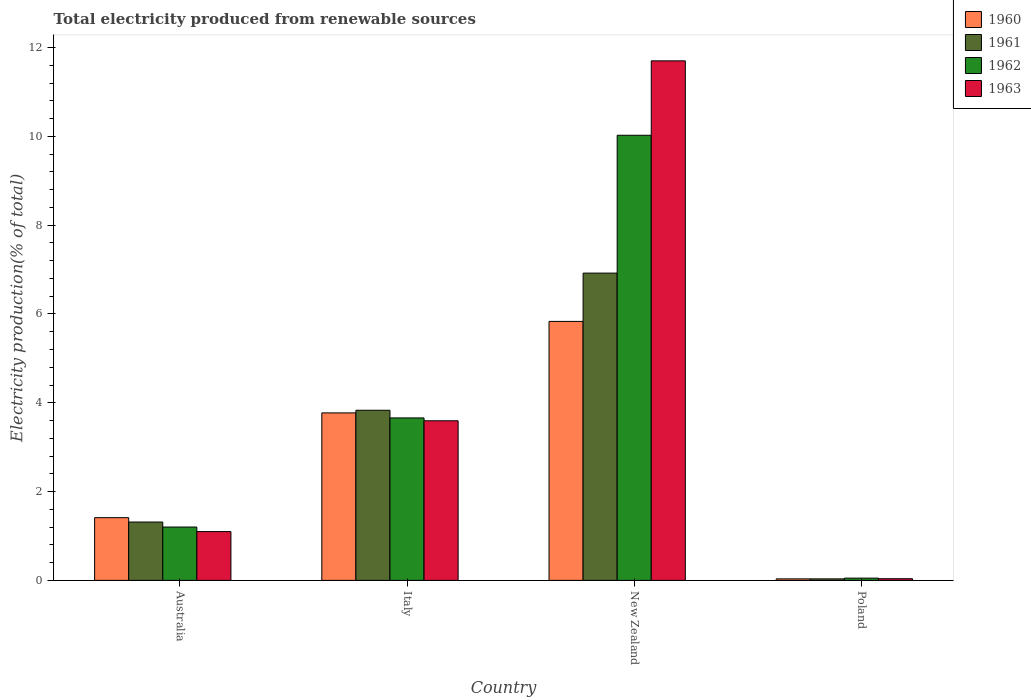How many different coloured bars are there?
Give a very brief answer. 4. How many groups of bars are there?
Your answer should be compact. 4. Are the number of bars per tick equal to the number of legend labels?
Provide a short and direct response. Yes. Are the number of bars on each tick of the X-axis equal?
Provide a succinct answer. Yes. How many bars are there on the 4th tick from the left?
Provide a succinct answer. 4. How many bars are there on the 3rd tick from the right?
Provide a short and direct response. 4. What is the label of the 3rd group of bars from the left?
Offer a very short reply. New Zealand. What is the total electricity produced in 1963 in New Zealand?
Give a very brief answer. 11.7. Across all countries, what is the maximum total electricity produced in 1962?
Your response must be concise. 10.02. Across all countries, what is the minimum total electricity produced in 1960?
Your answer should be very brief. 0.03. In which country was the total electricity produced in 1963 maximum?
Ensure brevity in your answer.  New Zealand. What is the total total electricity produced in 1961 in the graph?
Make the answer very short. 12.1. What is the difference between the total electricity produced in 1962 in New Zealand and that in Poland?
Keep it short and to the point. 9.97. What is the difference between the total electricity produced in 1962 in Australia and the total electricity produced in 1961 in Italy?
Your answer should be very brief. -2.63. What is the average total electricity produced in 1962 per country?
Your answer should be compact. 3.73. What is the difference between the total electricity produced of/in 1962 and total electricity produced of/in 1963 in Poland?
Your answer should be compact. 0.01. What is the ratio of the total electricity produced in 1961 in Australia to that in New Zealand?
Provide a short and direct response. 0.19. Is the difference between the total electricity produced in 1962 in Italy and New Zealand greater than the difference between the total electricity produced in 1963 in Italy and New Zealand?
Provide a short and direct response. Yes. What is the difference between the highest and the second highest total electricity produced in 1962?
Provide a short and direct response. -8.82. What is the difference between the highest and the lowest total electricity produced in 1963?
Give a very brief answer. 11.66. Is it the case that in every country, the sum of the total electricity produced in 1962 and total electricity produced in 1961 is greater than the total electricity produced in 1963?
Offer a very short reply. Yes. How many bars are there?
Offer a terse response. 16. Are all the bars in the graph horizontal?
Keep it short and to the point. No. Does the graph contain any zero values?
Your answer should be compact. No. How are the legend labels stacked?
Give a very brief answer. Vertical. What is the title of the graph?
Keep it short and to the point. Total electricity produced from renewable sources. What is the label or title of the X-axis?
Ensure brevity in your answer.  Country. What is the Electricity production(% of total) of 1960 in Australia?
Provide a succinct answer. 1.41. What is the Electricity production(% of total) of 1961 in Australia?
Provide a succinct answer. 1.31. What is the Electricity production(% of total) of 1962 in Australia?
Keep it short and to the point. 1.2. What is the Electricity production(% of total) of 1963 in Australia?
Your answer should be compact. 1.1. What is the Electricity production(% of total) of 1960 in Italy?
Provide a succinct answer. 3.77. What is the Electricity production(% of total) of 1961 in Italy?
Keep it short and to the point. 3.83. What is the Electricity production(% of total) of 1962 in Italy?
Make the answer very short. 3.66. What is the Electricity production(% of total) in 1963 in Italy?
Offer a very short reply. 3.59. What is the Electricity production(% of total) of 1960 in New Zealand?
Offer a terse response. 5.83. What is the Electricity production(% of total) in 1961 in New Zealand?
Ensure brevity in your answer.  6.92. What is the Electricity production(% of total) of 1962 in New Zealand?
Your answer should be very brief. 10.02. What is the Electricity production(% of total) in 1963 in New Zealand?
Your response must be concise. 11.7. What is the Electricity production(% of total) of 1960 in Poland?
Offer a terse response. 0.03. What is the Electricity production(% of total) in 1961 in Poland?
Your answer should be very brief. 0.03. What is the Electricity production(% of total) of 1962 in Poland?
Offer a terse response. 0.05. What is the Electricity production(% of total) in 1963 in Poland?
Your answer should be very brief. 0.04. Across all countries, what is the maximum Electricity production(% of total) in 1960?
Offer a terse response. 5.83. Across all countries, what is the maximum Electricity production(% of total) in 1961?
Ensure brevity in your answer.  6.92. Across all countries, what is the maximum Electricity production(% of total) of 1962?
Offer a very short reply. 10.02. Across all countries, what is the maximum Electricity production(% of total) in 1963?
Your answer should be compact. 11.7. Across all countries, what is the minimum Electricity production(% of total) in 1960?
Keep it short and to the point. 0.03. Across all countries, what is the minimum Electricity production(% of total) of 1961?
Your answer should be compact. 0.03. Across all countries, what is the minimum Electricity production(% of total) in 1962?
Make the answer very short. 0.05. Across all countries, what is the minimum Electricity production(% of total) of 1963?
Offer a terse response. 0.04. What is the total Electricity production(% of total) of 1960 in the graph?
Offer a terse response. 11.05. What is the total Electricity production(% of total) of 1962 in the graph?
Keep it short and to the point. 14.94. What is the total Electricity production(% of total) in 1963 in the graph?
Make the answer very short. 16.43. What is the difference between the Electricity production(% of total) in 1960 in Australia and that in Italy?
Your response must be concise. -2.36. What is the difference between the Electricity production(% of total) in 1961 in Australia and that in Italy?
Keep it short and to the point. -2.52. What is the difference between the Electricity production(% of total) of 1962 in Australia and that in Italy?
Provide a short and direct response. -2.46. What is the difference between the Electricity production(% of total) in 1963 in Australia and that in Italy?
Give a very brief answer. -2.5. What is the difference between the Electricity production(% of total) in 1960 in Australia and that in New Zealand?
Your response must be concise. -4.42. What is the difference between the Electricity production(% of total) of 1961 in Australia and that in New Zealand?
Your answer should be compact. -5.61. What is the difference between the Electricity production(% of total) in 1962 in Australia and that in New Zealand?
Your answer should be compact. -8.82. What is the difference between the Electricity production(% of total) of 1963 in Australia and that in New Zealand?
Your response must be concise. -10.6. What is the difference between the Electricity production(% of total) in 1960 in Australia and that in Poland?
Make the answer very short. 1.38. What is the difference between the Electricity production(% of total) of 1961 in Australia and that in Poland?
Make the answer very short. 1.28. What is the difference between the Electricity production(% of total) of 1962 in Australia and that in Poland?
Keep it short and to the point. 1.15. What is the difference between the Electricity production(% of total) of 1963 in Australia and that in Poland?
Provide a succinct answer. 1.06. What is the difference between the Electricity production(% of total) in 1960 in Italy and that in New Zealand?
Keep it short and to the point. -2.06. What is the difference between the Electricity production(% of total) in 1961 in Italy and that in New Zealand?
Keep it short and to the point. -3.09. What is the difference between the Electricity production(% of total) of 1962 in Italy and that in New Zealand?
Your response must be concise. -6.37. What is the difference between the Electricity production(% of total) in 1963 in Italy and that in New Zealand?
Provide a succinct answer. -8.11. What is the difference between the Electricity production(% of total) of 1960 in Italy and that in Poland?
Offer a terse response. 3.74. What is the difference between the Electricity production(% of total) in 1961 in Italy and that in Poland?
Your response must be concise. 3.8. What is the difference between the Electricity production(% of total) of 1962 in Italy and that in Poland?
Offer a very short reply. 3.61. What is the difference between the Electricity production(% of total) in 1963 in Italy and that in Poland?
Your answer should be very brief. 3.56. What is the difference between the Electricity production(% of total) of 1960 in New Zealand and that in Poland?
Provide a short and direct response. 5.8. What is the difference between the Electricity production(% of total) of 1961 in New Zealand and that in Poland?
Provide a short and direct response. 6.89. What is the difference between the Electricity production(% of total) of 1962 in New Zealand and that in Poland?
Your response must be concise. 9.97. What is the difference between the Electricity production(% of total) in 1963 in New Zealand and that in Poland?
Offer a very short reply. 11.66. What is the difference between the Electricity production(% of total) of 1960 in Australia and the Electricity production(% of total) of 1961 in Italy?
Give a very brief answer. -2.42. What is the difference between the Electricity production(% of total) in 1960 in Australia and the Electricity production(% of total) in 1962 in Italy?
Provide a short and direct response. -2.25. What is the difference between the Electricity production(% of total) of 1960 in Australia and the Electricity production(% of total) of 1963 in Italy?
Provide a short and direct response. -2.18. What is the difference between the Electricity production(% of total) in 1961 in Australia and the Electricity production(% of total) in 1962 in Italy?
Keep it short and to the point. -2.34. What is the difference between the Electricity production(% of total) of 1961 in Australia and the Electricity production(% of total) of 1963 in Italy?
Give a very brief answer. -2.28. What is the difference between the Electricity production(% of total) of 1962 in Australia and the Electricity production(% of total) of 1963 in Italy?
Provide a succinct answer. -2.39. What is the difference between the Electricity production(% of total) in 1960 in Australia and the Electricity production(% of total) in 1961 in New Zealand?
Offer a terse response. -5.51. What is the difference between the Electricity production(% of total) of 1960 in Australia and the Electricity production(% of total) of 1962 in New Zealand?
Your answer should be very brief. -8.61. What is the difference between the Electricity production(% of total) in 1960 in Australia and the Electricity production(% of total) in 1963 in New Zealand?
Give a very brief answer. -10.29. What is the difference between the Electricity production(% of total) in 1961 in Australia and the Electricity production(% of total) in 1962 in New Zealand?
Provide a succinct answer. -8.71. What is the difference between the Electricity production(% of total) in 1961 in Australia and the Electricity production(% of total) in 1963 in New Zealand?
Provide a short and direct response. -10.39. What is the difference between the Electricity production(% of total) in 1962 in Australia and the Electricity production(% of total) in 1963 in New Zealand?
Your answer should be compact. -10.5. What is the difference between the Electricity production(% of total) in 1960 in Australia and the Electricity production(% of total) in 1961 in Poland?
Your answer should be very brief. 1.38. What is the difference between the Electricity production(% of total) in 1960 in Australia and the Electricity production(% of total) in 1962 in Poland?
Your response must be concise. 1.36. What is the difference between the Electricity production(% of total) of 1960 in Australia and the Electricity production(% of total) of 1963 in Poland?
Give a very brief answer. 1.37. What is the difference between the Electricity production(% of total) in 1961 in Australia and the Electricity production(% of total) in 1962 in Poland?
Your response must be concise. 1.26. What is the difference between the Electricity production(% of total) of 1961 in Australia and the Electricity production(% of total) of 1963 in Poland?
Give a very brief answer. 1.28. What is the difference between the Electricity production(% of total) of 1962 in Australia and the Electricity production(% of total) of 1963 in Poland?
Offer a terse response. 1.16. What is the difference between the Electricity production(% of total) in 1960 in Italy and the Electricity production(% of total) in 1961 in New Zealand?
Provide a short and direct response. -3.15. What is the difference between the Electricity production(% of total) of 1960 in Italy and the Electricity production(% of total) of 1962 in New Zealand?
Your answer should be very brief. -6.25. What is the difference between the Electricity production(% of total) in 1960 in Italy and the Electricity production(% of total) in 1963 in New Zealand?
Provide a short and direct response. -7.93. What is the difference between the Electricity production(% of total) of 1961 in Italy and the Electricity production(% of total) of 1962 in New Zealand?
Ensure brevity in your answer.  -6.19. What is the difference between the Electricity production(% of total) in 1961 in Italy and the Electricity production(% of total) in 1963 in New Zealand?
Your response must be concise. -7.87. What is the difference between the Electricity production(% of total) of 1962 in Italy and the Electricity production(% of total) of 1963 in New Zealand?
Ensure brevity in your answer.  -8.04. What is the difference between the Electricity production(% of total) in 1960 in Italy and the Electricity production(% of total) in 1961 in Poland?
Your answer should be very brief. 3.74. What is the difference between the Electricity production(% of total) in 1960 in Italy and the Electricity production(% of total) in 1962 in Poland?
Offer a very short reply. 3.72. What is the difference between the Electricity production(% of total) in 1960 in Italy and the Electricity production(% of total) in 1963 in Poland?
Give a very brief answer. 3.73. What is the difference between the Electricity production(% of total) in 1961 in Italy and the Electricity production(% of total) in 1962 in Poland?
Ensure brevity in your answer.  3.78. What is the difference between the Electricity production(% of total) of 1961 in Italy and the Electricity production(% of total) of 1963 in Poland?
Make the answer very short. 3.79. What is the difference between the Electricity production(% of total) of 1962 in Italy and the Electricity production(% of total) of 1963 in Poland?
Keep it short and to the point. 3.62. What is the difference between the Electricity production(% of total) of 1960 in New Zealand and the Electricity production(% of total) of 1961 in Poland?
Offer a very short reply. 5.8. What is the difference between the Electricity production(% of total) of 1960 in New Zealand and the Electricity production(% of total) of 1962 in Poland?
Provide a succinct answer. 5.78. What is the difference between the Electricity production(% of total) of 1960 in New Zealand and the Electricity production(% of total) of 1963 in Poland?
Ensure brevity in your answer.  5.79. What is the difference between the Electricity production(% of total) of 1961 in New Zealand and the Electricity production(% of total) of 1962 in Poland?
Provide a succinct answer. 6.87. What is the difference between the Electricity production(% of total) in 1961 in New Zealand and the Electricity production(% of total) in 1963 in Poland?
Make the answer very short. 6.88. What is the difference between the Electricity production(% of total) of 1962 in New Zealand and the Electricity production(% of total) of 1963 in Poland?
Ensure brevity in your answer.  9.99. What is the average Electricity production(% of total) of 1960 per country?
Offer a terse response. 2.76. What is the average Electricity production(% of total) of 1961 per country?
Your answer should be compact. 3.02. What is the average Electricity production(% of total) in 1962 per country?
Your answer should be very brief. 3.73. What is the average Electricity production(% of total) in 1963 per country?
Make the answer very short. 4.11. What is the difference between the Electricity production(% of total) of 1960 and Electricity production(% of total) of 1961 in Australia?
Ensure brevity in your answer.  0.1. What is the difference between the Electricity production(% of total) in 1960 and Electricity production(% of total) in 1962 in Australia?
Your response must be concise. 0.21. What is the difference between the Electricity production(% of total) of 1960 and Electricity production(% of total) of 1963 in Australia?
Offer a terse response. 0.31. What is the difference between the Electricity production(% of total) in 1961 and Electricity production(% of total) in 1962 in Australia?
Ensure brevity in your answer.  0.11. What is the difference between the Electricity production(% of total) in 1961 and Electricity production(% of total) in 1963 in Australia?
Give a very brief answer. 0.21. What is the difference between the Electricity production(% of total) in 1962 and Electricity production(% of total) in 1963 in Australia?
Ensure brevity in your answer.  0.1. What is the difference between the Electricity production(% of total) in 1960 and Electricity production(% of total) in 1961 in Italy?
Your answer should be compact. -0.06. What is the difference between the Electricity production(% of total) of 1960 and Electricity production(% of total) of 1962 in Italy?
Provide a short and direct response. 0.11. What is the difference between the Electricity production(% of total) in 1960 and Electricity production(% of total) in 1963 in Italy?
Your answer should be very brief. 0.18. What is the difference between the Electricity production(% of total) in 1961 and Electricity production(% of total) in 1962 in Italy?
Keep it short and to the point. 0.17. What is the difference between the Electricity production(% of total) of 1961 and Electricity production(% of total) of 1963 in Italy?
Your answer should be very brief. 0.24. What is the difference between the Electricity production(% of total) in 1962 and Electricity production(% of total) in 1963 in Italy?
Provide a short and direct response. 0.06. What is the difference between the Electricity production(% of total) in 1960 and Electricity production(% of total) in 1961 in New Zealand?
Give a very brief answer. -1.09. What is the difference between the Electricity production(% of total) of 1960 and Electricity production(% of total) of 1962 in New Zealand?
Give a very brief answer. -4.19. What is the difference between the Electricity production(% of total) in 1960 and Electricity production(% of total) in 1963 in New Zealand?
Keep it short and to the point. -5.87. What is the difference between the Electricity production(% of total) in 1961 and Electricity production(% of total) in 1962 in New Zealand?
Offer a very short reply. -3.1. What is the difference between the Electricity production(% of total) in 1961 and Electricity production(% of total) in 1963 in New Zealand?
Your answer should be very brief. -4.78. What is the difference between the Electricity production(% of total) of 1962 and Electricity production(% of total) of 1963 in New Zealand?
Offer a terse response. -1.68. What is the difference between the Electricity production(% of total) in 1960 and Electricity production(% of total) in 1962 in Poland?
Keep it short and to the point. -0.02. What is the difference between the Electricity production(% of total) in 1960 and Electricity production(% of total) in 1963 in Poland?
Offer a very short reply. -0. What is the difference between the Electricity production(% of total) in 1961 and Electricity production(% of total) in 1962 in Poland?
Your answer should be compact. -0.02. What is the difference between the Electricity production(% of total) in 1961 and Electricity production(% of total) in 1963 in Poland?
Provide a succinct answer. -0. What is the difference between the Electricity production(% of total) of 1962 and Electricity production(% of total) of 1963 in Poland?
Provide a short and direct response. 0.01. What is the ratio of the Electricity production(% of total) of 1960 in Australia to that in Italy?
Your response must be concise. 0.37. What is the ratio of the Electricity production(% of total) of 1961 in Australia to that in Italy?
Your answer should be compact. 0.34. What is the ratio of the Electricity production(% of total) of 1962 in Australia to that in Italy?
Provide a short and direct response. 0.33. What is the ratio of the Electricity production(% of total) in 1963 in Australia to that in Italy?
Give a very brief answer. 0.31. What is the ratio of the Electricity production(% of total) of 1960 in Australia to that in New Zealand?
Your answer should be very brief. 0.24. What is the ratio of the Electricity production(% of total) in 1961 in Australia to that in New Zealand?
Your answer should be very brief. 0.19. What is the ratio of the Electricity production(% of total) of 1962 in Australia to that in New Zealand?
Give a very brief answer. 0.12. What is the ratio of the Electricity production(% of total) of 1963 in Australia to that in New Zealand?
Provide a short and direct response. 0.09. What is the ratio of the Electricity production(% of total) of 1960 in Australia to that in Poland?
Your answer should be very brief. 41.37. What is the ratio of the Electricity production(% of total) of 1961 in Australia to that in Poland?
Provide a short and direct response. 38.51. What is the ratio of the Electricity production(% of total) in 1962 in Australia to that in Poland?
Your answer should be very brief. 23.61. What is the ratio of the Electricity production(% of total) of 1963 in Australia to that in Poland?
Provide a succinct answer. 29. What is the ratio of the Electricity production(% of total) in 1960 in Italy to that in New Zealand?
Offer a very short reply. 0.65. What is the ratio of the Electricity production(% of total) of 1961 in Italy to that in New Zealand?
Offer a very short reply. 0.55. What is the ratio of the Electricity production(% of total) in 1962 in Italy to that in New Zealand?
Keep it short and to the point. 0.36. What is the ratio of the Electricity production(% of total) of 1963 in Italy to that in New Zealand?
Offer a very short reply. 0.31. What is the ratio of the Electricity production(% of total) in 1960 in Italy to that in Poland?
Your answer should be compact. 110.45. What is the ratio of the Electricity production(% of total) in 1961 in Italy to that in Poland?
Your answer should be very brief. 112.3. What is the ratio of the Electricity production(% of total) of 1962 in Italy to that in Poland?
Your answer should be compact. 71.88. What is the ratio of the Electricity production(% of total) in 1963 in Italy to that in Poland?
Offer a very short reply. 94.84. What is the ratio of the Electricity production(% of total) of 1960 in New Zealand to that in Poland?
Your answer should be compact. 170.79. What is the ratio of the Electricity production(% of total) in 1961 in New Zealand to that in Poland?
Give a very brief answer. 202.83. What is the ratio of the Electricity production(% of total) of 1962 in New Zealand to that in Poland?
Your answer should be compact. 196.95. What is the ratio of the Electricity production(% of total) in 1963 in New Zealand to that in Poland?
Offer a very short reply. 308.73. What is the difference between the highest and the second highest Electricity production(% of total) of 1960?
Your answer should be very brief. 2.06. What is the difference between the highest and the second highest Electricity production(% of total) in 1961?
Your response must be concise. 3.09. What is the difference between the highest and the second highest Electricity production(% of total) of 1962?
Your answer should be compact. 6.37. What is the difference between the highest and the second highest Electricity production(% of total) in 1963?
Offer a terse response. 8.11. What is the difference between the highest and the lowest Electricity production(% of total) in 1960?
Ensure brevity in your answer.  5.8. What is the difference between the highest and the lowest Electricity production(% of total) in 1961?
Provide a short and direct response. 6.89. What is the difference between the highest and the lowest Electricity production(% of total) of 1962?
Provide a succinct answer. 9.97. What is the difference between the highest and the lowest Electricity production(% of total) in 1963?
Offer a very short reply. 11.66. 